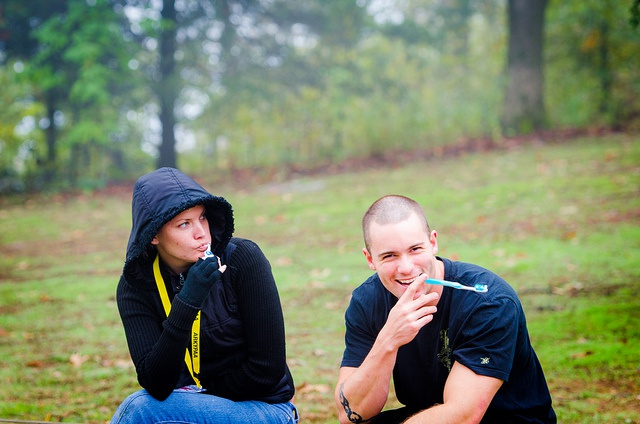Describe the objects in this image and their specific colors. I can see people in darkblue, black, pink, lightpink, and navy tones, people in darkblue, black, navy, blue, and gray tones, toothbrush in darkblue, white, and lightblue tones, toothbrush in darkblue, white, and lightblue tones, and toothbrush in lightgray, darkgray, lightpink, darkblue, and white tones in this image. 